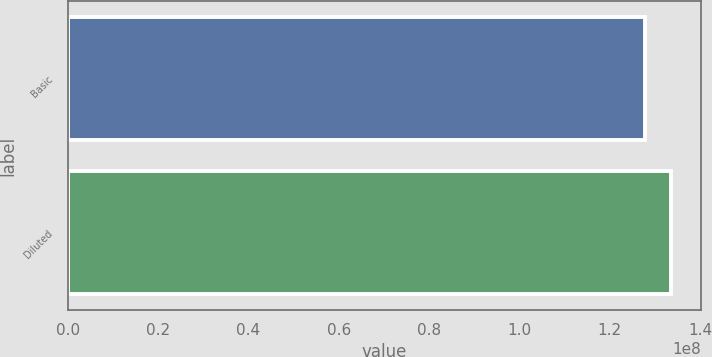Convert chart to OTSL. <chart><loc_0><loc_0><loc_500><loc_500><bar_chart><fcel>Basic<fcel>Diluted<nl><fcel>1.27874e+08<fcel>1.33652e+08<nl></chart> 